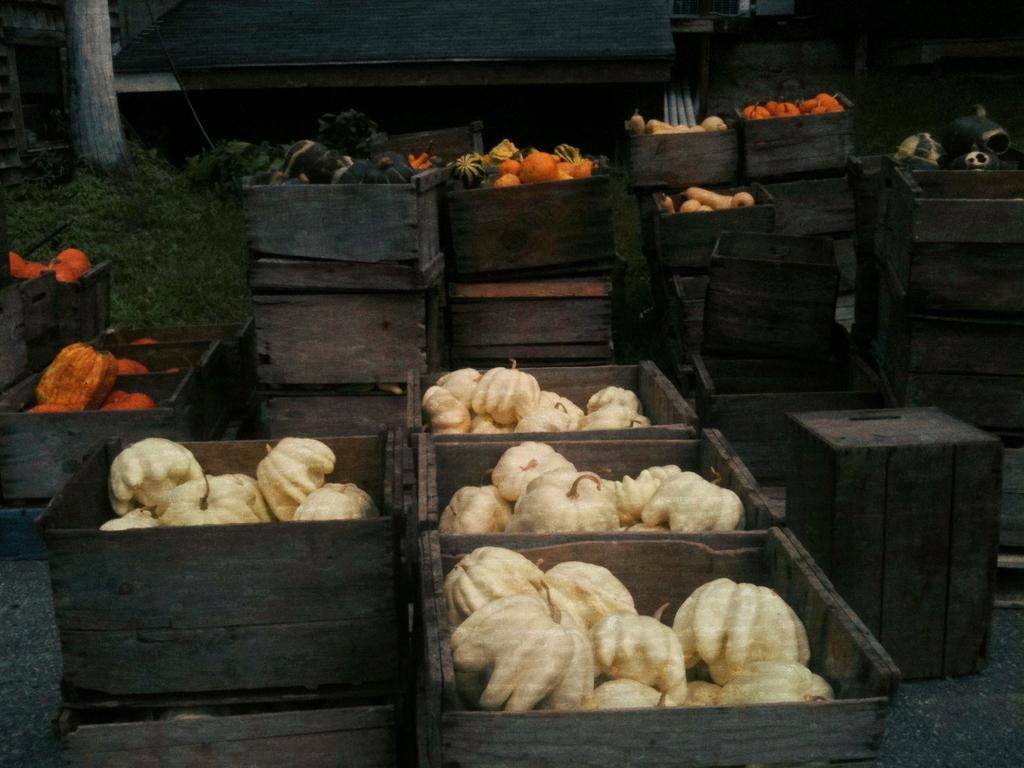How would you summarize this image in a sentence or two? In front of the image there are vegetables in wooden boxes, behind the boxes there are plants, trees and houses. 